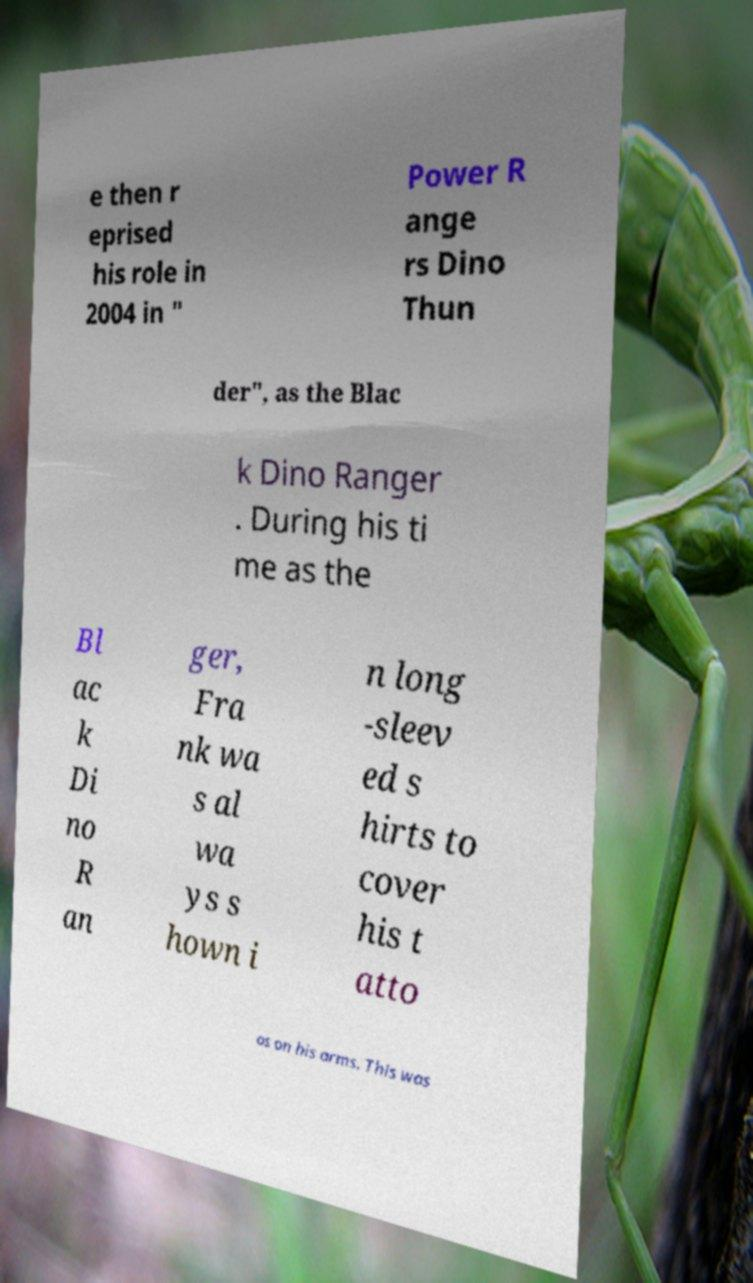Can you read and provide the text displayed in the image?This photo seems to have some interesting text. Can you extract and type it out for me? e then r eprised his role in 2004 in " Power R ange rs Dino Thun der", as the Blac k Dino Ranger . During his ti me as the Bl ac k Di no R an ger, Fra nk wa s al wa ys s hown i n long -sleev ed s hirts to cover his t atto os on his arms. This was 